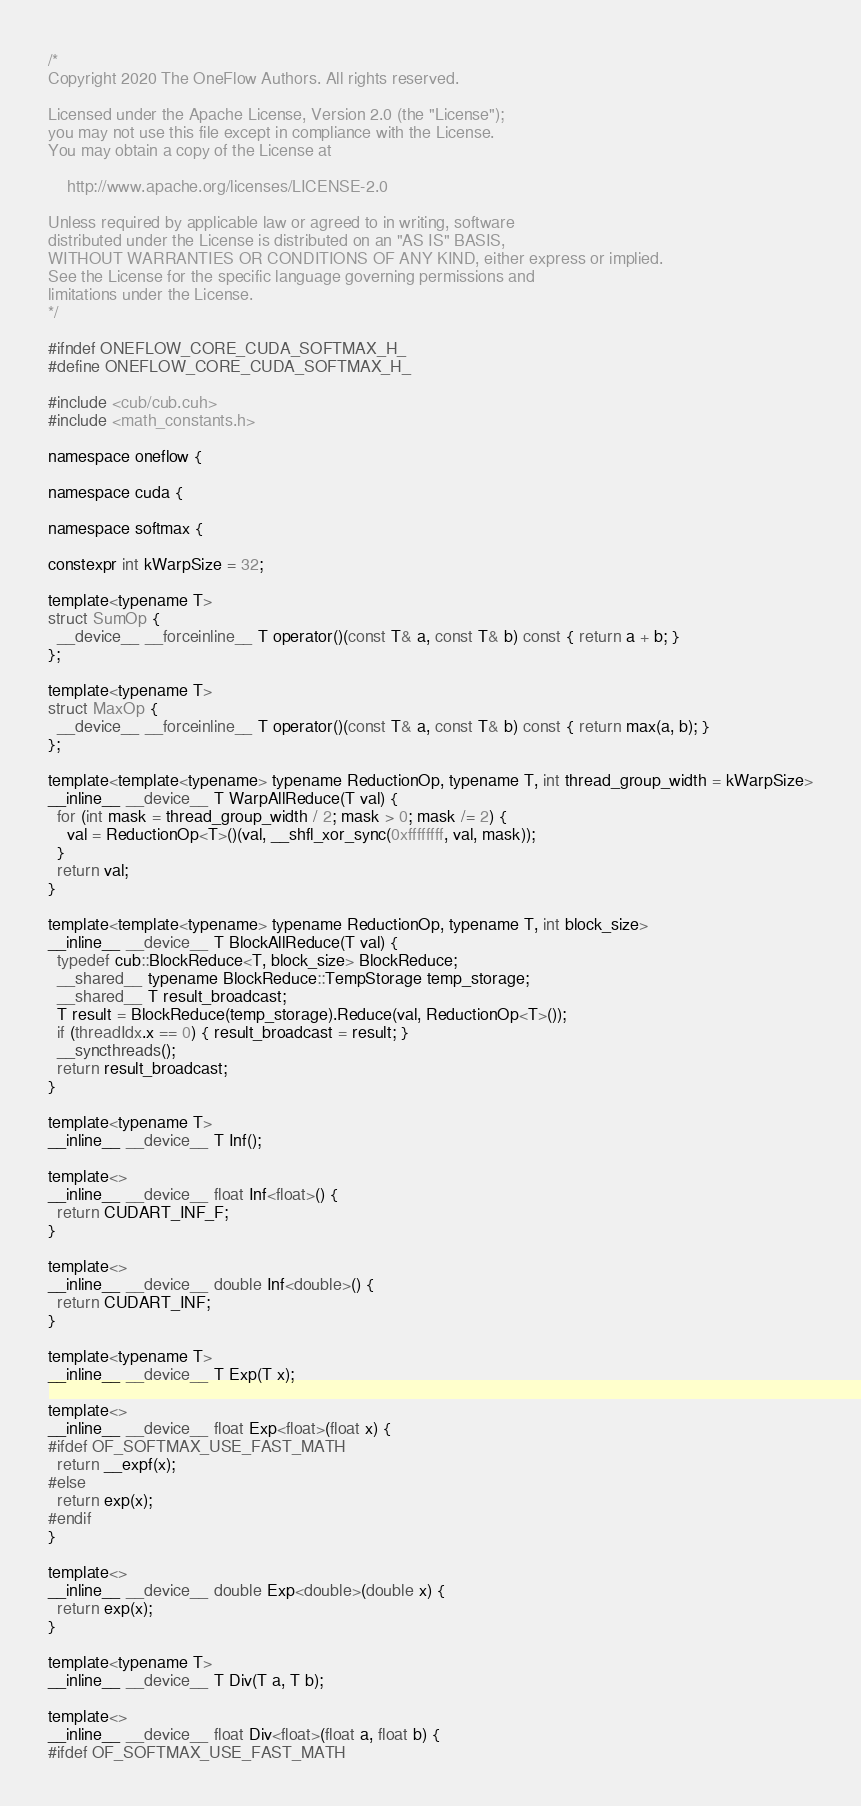Convert code to text. <code><loc_0><loc_0><loc_500><loc_500><_Cuda_>/*
Copyright 2020 The OneFlow Authors. All rights reserved.

Licensed under the Apache License, Version 2.0 (the "License");
you may not use this file except in compliance with the License.
You may obtain a copy of the License at

    http://www.apache.org/licenses/LICENSE-2.0

Unless required by applicable law or agreed to in writing, software
distributed under the License is distributed on an "AS IS" BASIS,
WITHOUT WARRANTIES OR CONDITIONS OF ANY KIND, either express or implied.
See the License for the specific language governing permissions and
limitations under the License.
*/

#ifndef ONEFLOW_CORE_CUDA_SOFTMAX_H_
#define ONEFLOW_CORE_CUDA_SOFTMAX_H_

#include <cub/cub.cuh>
#include <math_constants.h>

namespace oneflow {

namespace cuda {

namespace softmax {

constexpr int kWarpSize = 32;

template<typename T>
struct SumOp {
  __device__ __forceinline__ T operator()(const T& a, const T& b) const { return a + b; }
};

template<typename T>
struct MaxOp {
  __device__ __forceinline__ T operator()(const T& a, const T& b) const { return max(a, b); }
};

template<template<typename> typename ReductionOp, typename T, int thread_group_width = kWarpSize>
__inline__ __device__ T WarpAllReduce(T val) {
  for (int mask = thread_group_width / 2; mask > 0; mask /= 2) {
    val = ReductionOp<T>()(val, __shfl_xor_sync(0xffffffff, val, mask));
  }
  return val;
}

template<template<typename> typename ReductionOp, typename T, int block_size>
__inline__ __device__ T BlockAllReduce(T val) {
  typedef cub::BlockReduce<T, block_size> BlockReduce;
  __shared__ typename BlockReduce::TempStorage temp_storage;
  __shared__ T result_broadcast;
  T result = BlockReduce(temp_storage).Reduce(val, ReductionOp<T>());
  if (threadIdx.x == 0) { result_broadcast = result; }
  __syncthreads();
  return result_broadcast;
}

template<typename T>
__inline__ __device__ T Inf();

template<>
__inline__ __device__ float Inf<float>() {
  return CUDART_INF_F;
}

template<>
__inline__ __device__ double Inf<double>() {
  return CUDART_INF;
}

template<typename T>
__inline__ __device__ T Exp(T x);

template<>
__inline__ __device__ float Exp<float>(float x) {
#ifdef OF_SOFTMAX_USE_FAST_MATH
  return __expf(x);
#else
  return exp(x);
#endif
}

template<>
__inline__ __device__ double Exp<double>(double x) {
  return exp(x);
}

template<typename T>
__inline__ __device__ T Div(T a, T b);

template<>
__inline__ __device__ float Div<float>(float a, float b) {
#ifdef OF_SOFTMAX_USE_FAST_MATH</code> 